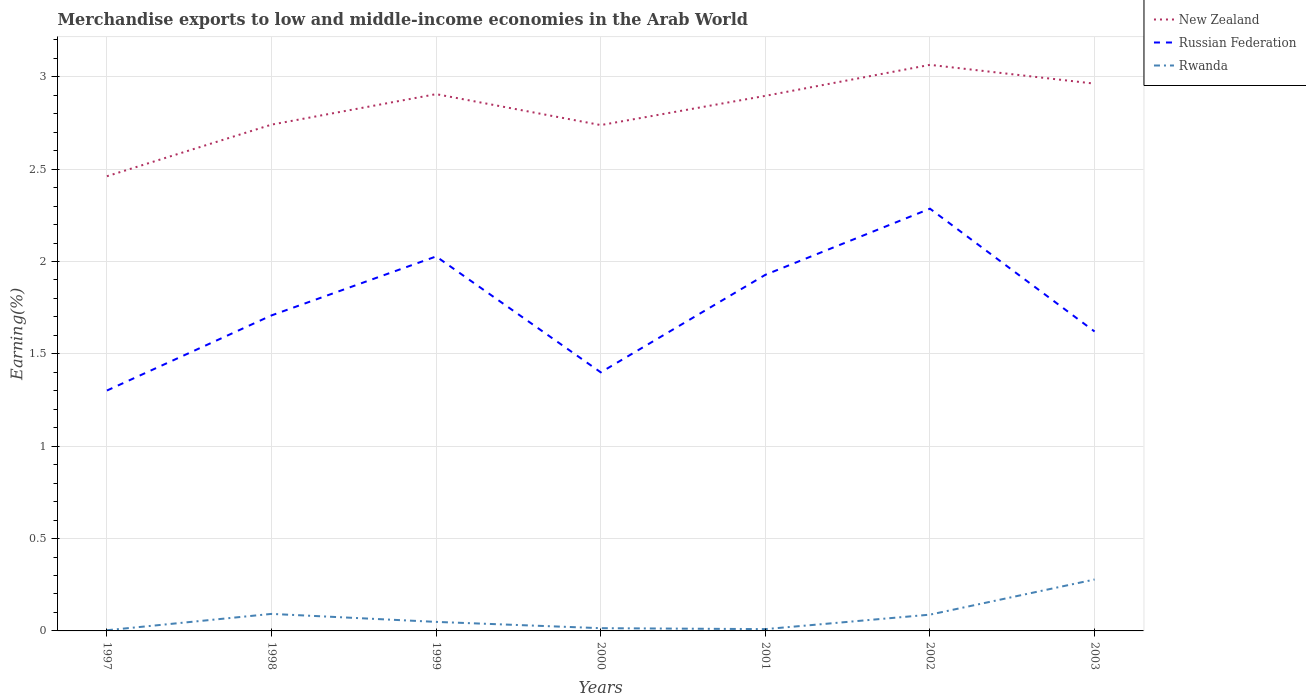How many different coloured lines are there?
Provide a short and direct response. 3. Does the line corresponding to Russian Federation intersect with the line corresponding to Rwanda?
Your answer should be compact. No. Is the number of lines equal to the number of legend labels?
Make the answer very short. Yes. Across all years, what is the maximum percentage of amount earned from merchandise exports in New Zealand?
Ensure brevity in your answer.  2.46. In which year was the percentage of amount earned from merchandise exports in Rwanda maximum?
Offer a terse response. 1997. What is the total percentage of amount earned from merchandise exports in Rwanda in the graph?
Keep it short and to the point. 0. What is the difference between the highest and the second highest percentage of amount earned from merchandise exports in Rwanda?
Your answer should be compact. 0.27. How many years are there in the graph?
Ensure brevity in your answer.  7. What is the difference between two consecutive major ticks on the Y-axis?
Provide a succinct answer. 0.5. Where does the legend appear in the graph?
Offer a terse response. Top right. How many legend labels are there?
Make the answer very short. 3. What is the title of the graph?
Give a very brief answer. Merchandise exports to low and middle-income economies in the Arab World. What is the label or title of the X-axis?
Your answer should be very brief. Years. What is the label or title of the Y-axis?
Offer a very short reply. Earning(%). What is the Earning(%) in New Zealand in 1997?
Your answer should be very brief. 2.46. What is the Earning(%) of Russian Federation in 1997?
Keep it short and to the point. 1.3. What is the Earning(%) in Rwanda in 1997?
Ensure brevity in your answer.  0. What is the Earning(%) of New Zealand in 1998?
Offer a very short reply. 2.74. What is the Earning(%) of Russian Federation in 1998?
Your answer should be very brief. 1.71. What is the Earning(%) of Rwanda in 1998?
Give a very brief answer. 0.09. What is the Earning(%) in New Zealand in 1999?
Your answer should be very brief. 2.91. What is the Earning(%) in Russian Federation in 1999?
Your answer should be compact. 2.03. What is the Earning(%) of Rwanda in 1999?
Give a very brief answer. 0.05. What is the Earning(%) in New Zealand in 2000?
Your answer should be compact. 2.74. What is the Earning(%) in Russian Federation in 2000?
Your answer should be compact. 1.4. What is the Earning(%) in Rwanda in 2000?
Keep it short and to the point. 0.01. What is the Earning(%) in New Zealand in 2001?
Keep it short and to the point. 2.9. What is the Earning(%) in Russian Federation in 2001?
Your response must be concise. 1.93. What is the Earning(%) of Rwanda in 2001?
Offer a very short reply. 0.01. What is the Earning(%) of New Zealand in 2002?
Make the answer very short. 3.06. What is the Earning(%) in Russian Federation in 2002?
Your response must be concise. 2.29. What is the Earning(%) of Rwanda in 2002?
Provide a succinct answer. 0.09. What is the Earning(%) of New Zealand in 2003?
Give a very brief answer. 2.96. What is the Earning(%) of Russian Federation in 2003?
Keep it short and to the point. 1.62. What is the Earning(%) in Rwanda in 2003?
Provide a short and direct response. 0.28. Across all years, what is the maximum Earning(%) in New Zealand?
Provide a succinct answer. 3.06. Across all years, what is the maximum Earning(%) in Russian Federation?
Give a very brief answer. 2.29. Across all years, what is the maximum Earning(%) in Rwanda?
Offer a very short reply. 0.28. Across all years, what is the minimum Earning(%) in New Zealand?
Your answer should be very brief. 2.46. Across all years, what is the minimum Earning(%) of Russian Federation?
Ensure brevity in your answer.  1.3. Across all years, what is the minimum Earning(%) in Rwanda?
Provide a succinct answer. 0. What is the total Earning(%) of New Zealand in the graph?
Ensure brevity in your answer.  19.77. What is the total Earning(%) in Russian Federation in the graph?
Your response must be concise. 12.27. What is the total Earning(%) of Rwanda in the graph?
Your answer should be very brief. 0.54. What is the difference between the Earning(%) of New Zealand in 1997 and that in 1998?
Your answer should be very brief. -0.28. What is the difference between the Earning(%) of Russian Federation in 1997 and that in 1998?
Make the answer very short. -0.41. What is the difference between the Earning(%) in Rwanda in 1997 and that in 1998?
Offer a very short reply. -0.09. What is the difference between the Earning(%) of New Zealand in 1997 and that in 1999?
Give a very brief answer. -0.44. What is the difference between the Earning(%) of Russian Federation in 1997 and that in 1999?
Provide a succinct answer. -0.73. What is the difference between the Earning(%) of Rwanda in 1997 and that in 1999?
Make the answer very short. -0.05. What is the difference between the Earning(%) in New Zealand in 1997 and that in 2000?
Your response must be concise. -0.28. What is the difference between the Earning(%) of Russian Federation in 1997 and that in 2000?
Your response must be concise. -0.1. What is the difference between the Earning(%) of Rwanda in 1997 and that in 2000?
Your answer should be very brief. -0.01. What is the difference between the Earning(%) in New Zealand in 1997 and that in 2001?
Your response must be concise. -0.44. What is the difference between the Earning(%) in Russian Federation in 1997 and that in 2001?
Offer a terse response. -0.63. What is the difference between the Earning(%) of Rwanda in 1997 and that in 2001?
Make the answer very short. -0.01. What is the difference between the Earning(%) in New Zealand in 1997 and that in 2002?
Provide a short and direct response. -0.6. What is the difference between the Earning(%) of Russian Federation in 1997 and that in 2002?
Make the answer very short. -0.98. What is the difference between the Earning(%) of Rwanda in 1997 and that in 2002?
Give a very brief answer. -0.08. What is the difference between the Earning(%) in New Zealand in 1997 and that in 2003?
Your answer should be compact. -0.5. What is the difference between the Earning(%) of Russian Federation in 1997 and that in 2003?
Provide a short and direct response. -0.32. What is the difference between the Earning(%) of Rwanda in 1997 and that in 2003?
Your answer should be compact. -0.27. What is the difference between the Earning(%) of New Zealand in 1998 and that in 1999?
Offer a terse response. -0.17. What is the difference between the Earning(%) of Russian Federation in 1998 and that in 1999?
Offer a terse response. -0.32. What is the difference between the Earning(%) of Rwanda in 1998 and that in 1999?
Offer a terse response. 0.04. What is the difference between the Earning(%) of New Zealand in 1998 and that in 2000?
Your answer should be very brief. 0. What is the difference between the Earning(%) in Russian Federation in 1998 and that in 2000?
Make the answer very short. 0.31. What is the difference between the Earning(%) of Rwanda in 1998 and that in 2000?
Your response must be concise. 0.08. What is the difference between the Earning(%) in New Zealand in 1998 and that in 2001?
Keep it short and to the point. -0.16. What is the difference between the Earning(%) of Russian Federation in 1998 and that in 2001?
Your answer should be very brief. -0.22. What is the difference between the Earning(%) in Rwanda in 1998 and that in 2001?
Offer a terse response. 0.08. What is the difference between the Earning(%) of New Zealand in 1998 and that in 2002?
Your response must be concise. -0.32. What is the difference between the Earning(%) of Russian Federation in 1998 and that in 2002?
Your answer should be compact. -0.58. What is the difference between the Earning(%) in Rwanda in 1998 and that in 2002?
Your answer should be compact. 0. What is the difference between the Earning(%) in New Zealand in 1998 and that in 2003?
Your response must be concise. -0.22. What is the difference between the Earning(%) in Russian Federation in 1998 and that in 2003?
Keep it short and to the point. 0.09. What is the difference between the Earning(%) of Rwanda in 1998 and that in 2003?
Your answer should be compact. -0.19. What is the difference between the Earning(%) in New Zealand in 1999 and that in 2000?
Offer a terse response. 0.17. What is the difference between the Earning(%) of Russian Federation in 1999 and that in 2000?
Provide a succinct answer. 0.63. What is the difference between the Earning(%) of Rwanda in 1999 and that in 2000?
Ensure brevity in your answer.  0.03. What is the difference between the Earning(%) of New Zealand in 1999 and that in 2001?
Provide a short and direct response. 0.01. What is the difference between the Earning(%) of Russian Federation in 1999 and that in 2001?
Your answer should be compact. 0.1. What is the difference between the Earning(%) of Rwanda in 1999 and that in 2001?
Keep it short and to the point. 0.04. What is the difference between the Earning(%) of New Zealand in 1999 and that in 2002?
Your response must be concise. -0.16. What is the difference between the Earning(%) in Russian Federation in 1999 and that in 2002?
Ensure brevity in your answer.  -0.26. What is the difference between the Earning(%) of Rwanda in 1999 and that in 2002?
Give a very brief answer. -0.04. What is the difference between the Earning(%) in New Zealand in 1999 and that in 2003?
Your answer should be compact. -0.06. What is the difference between the Earning(%) in Russian Federation in 1999 and that in 2003?
Make the answer very short. 0.41. What is the difference between the Earning(%) of Rwanda in 1999 and that in 2003?
Offer a terse response. -0.23. What is the difference between the Earning(%) in New Zealand in 2000 and that in 2001?
Offer a very short reply. -0.16. What is the difference between the Earning(%) in Russian Federation in 2000 and that in 2001?
Provide a short and direct response. -0.53. What is the difference between the Earning(%) of Rwanda in 2000 and that in 2001?
Your response must be concise. 0.01. What is the difference between the Earning(%) of New Zealand in 2000 and that in 2002?
Make the answer very short. -0.33. What is the difference between the Earning(%) in Russian Federation in 2000 and that in 2002?
Make the answer very short. -0.89. What is the difference between the Earning(%) of Rwanda in 2000 and that in 2002?
Offer a very short reply. -0.07. What is the difference between the Earning(%) of New Zealand in 2000 and that in 2003?
Give a very brief answer. -0.22. What is the difference between the Earning(%) in Russian Federation in 2000 and that in 2003?
Provide a succinct answer. -0.22. What is the difference between the Earning(%) in Rwanda in 2000 and that in 2003?
Keep it short and to the point. -0.26. What is the difference between the Earning(%) of New Zealand in 2001 and that in 2002?
Give a very brief answer. -0.17. What is the difference between the Earning(%) in Russian Federation in 2001 and that in 2002?
Offer a terse response. -0.36. What is the difference between the Earning(%) of Rwanda in 2001 and that in 2002?
Your answer should be very brief. -0.08. What is the difference between the Earning(%) in New Zealand in 2001 and that in 2003?
Keep it short and to the point. -0.07. What is the difference between the Earning(%) in Russian Federation in 2001 and that in 2003?
Give a very brief answer. 0.31. What is the difference between the Earning(%) in Rwanda in 2001 and that in 2003?
Make the answer very short. -0.27. What is the difference between the Earning(%) of New Zealand in 2002 and that in 2003?
Offer a very short reply. 0.1. What is the difference between the Earning(%) in Russian Federation in 2002 and that in 2003?
Keep it short and to the point. 0.67. What is the difference between the Earning(%) of Rwanda in 2002 and that in 2003?
Make the answer very short. -0.19. What is the difference between the Earning(%) in New Zealand in 1997 and the Earning(%) in Russian Federation in 1998?
Make the answer very short. 0.75. What is the difference between the Earning(%) of New Zealand in 1997 and the Earning(%) of Rwanda in 1998?
Keep it short and to the point. 2.37. What is the difference between the Earning(%) of Russian Federation in 1997 and the Earning(%) of Rwanda in 1998?
Offer a very short reply. 1.21. What is the difference between the Earning(%) of New Zealand in 1997 and the Earning(%) of Russian Federation in 1999?
Provide a short and direct response. 0.43. What is the difference between the Earning(%) in New Zealand in 1997 and the Earning(%) in Rwanda in 1999?
Keep it short and to the point. 2.41. What is the difference between the Earning(%) of Russian Federation in 1997 and the Earning(%) of Rwanda in 1999?
Offer a very short reply. 1.25. What is the difference between the Earning(%) of New Zealand in 1997 and the Earning(%) of Russian Federation in 2000?
Make the answer very short. 1.06. What is the difference between the Earning(%) of New Zealand in 1997 and the Earning(%) of Rwanda in 2000?
Offer a very short reply. 2.45. What is the difference between the Earning(%) of Russian Federation in 1997 and the Earning(%) of Rwanda in 2000?
Give a very brief answer. 1.29. What is the difference between the Earning(%) in New Zealand in 1997 and the Earning(%) in Russian Federation in 2001?
Your answer should be very brief. 0.53. What is the difference between the Earning(%) of New Zealand in 1997 and the Earning(%) of Rwanda in 2001?
Ensure brevity in your answer.  2.45. What is the difference between the Earning(%) in Russian Federation in 1997 and the Earning(%) in Rwanda in 2001?
Provide a short and direct response. 1.29. What is the difference between the Earning(%) of New Zealand in 1997 and the Earning(%) of Russian Federation in 2002?
Give a very brief answer. 0.18. What is the difference between the Earning(%) in New Zealand in 1997 and the Earning(%) in Rwanda in 2002?
Provide a short and direct response. 2.37. What is the difference between the Earning(%) of Russian Federation in 1997 and the Earning(%) of Rwanda in 2002?
Keep it short and to the point. 1.21. What is the difference between the Earning(%) in New Zealand in 1997 and the Earning(%) in Russian Federation in 2003?
Your answer should be compact. 0.84. What is the difference between the Earning(%) in New Zealand in 1997 and the Earning(%) in Rwanda in 2003?
Make the answer very short. 2.18. What is the difference between the Earning(%) in New Zealand in 1998 and the Earning(%) in Russian Federation in 1999?
Your response must be concise. 0.71. What is the difference between the Earning(%) in New Zealand in 1998 and the Earning(%) in Rwanda in 1999?
Give a very brief answer. 2.69. What is the difference between the Earning(%) of Russian Federation in 1998 and the Earning(%) of Rwanda in 1999?
Your answer should be very brief. 1.66. What is the difference between the Earning(%) in New Zealand in 1998 and the Earning(%) in Russian Federation in 2000?
Your response must be concise. 1.34. What is the difference between the Earning(%) of New Zealand in 1998 and the Earning(%) of Rwanda in 2000?
Offer a very short reply. 2.73. What is the difference between the Earning(%) of Russian Federation in 1998 and the Earning(%) of Rwanda in 2000?
Ensure brevity in your answer.  1.69. What is the difference between the Earning(%) of New Zealand in 1998 and the Earning(%) of Russian Federation in 2001?
Your response must be concise. 0.81. What is the difference between the Earning(%) in New Zealand in 1998 and the Earning(%) in Rwanda in 2001?
Ensure brevity in your answer.  2.73. What is the difference between the Earning(%) in Russian Federation in 1998 and the Earning(%) in Rwanda in 2001?
Ensure brevity in your answer.  1.7. What is the difference between the Earning(%) of New Zealand in 1998 and the Earning(%) of Russian Federation in 2002?
Keep it short and to the point. 0.46. What is the difference between the Earning(%) in New Zealand in 1998 and the Earning(%) in Rwanda in 2002?
Your response must be concise. 2.65. What is the difference between the Earning(%) of Russian Federation in 1998 and the Earning(%) of Rwanda in 2002?
Your response must be concise. 1.62. What is the difference between the Earning(%) in New Zealand in 1998 and the Earning(%) in Russian Federation in 2003?
Your answer should be very brief. 1.12. What is the difference between the Earning(%) in New Zealand in 1998 and the Earning(%) in Rwanda in 2003?
Give a very brief answer. 2.46. What is the difference between the Earning(%) in Russian Federation in 1998 and the Earning(%) in Rwanda in 2003?
Your answer should be very brief. 1.43. What is the difference between the Earning(%) of New Zealand in 1999 and the Earning(%) of Russian Federation in 2000?
Provide a succinct answer. 1.51. What is the difference between the Earning(%) of New Zealand in 1999 and the Earning(%) of Rwanda in 2000?
Your answer should be very brief. 2.89. What is the difference between the Earning(%) of Russian Federation in 1999 and the Earning(%) of Rwanda in 2000?
Ensure brevity in your answer.  2.01. What is the difference between the Earning(%) in New Zealand in 1999 and the Earning(%) in Russian Federation in 2001?
Offer a terse response. 0.98. What is the difference between the Earning(%) in New Zealand in 1999 and the Earning(%) in Rwanda in 2001?
Offer a terse response. 2.9. What is the difference between the Earning(%) of Russian Federation in 1999 and the Earning(%) of Rwanda in 2001?
Ensure brevity in your answer.  2.02. What is the difference between the Earning(%) of New Zealand in 1999 and the Earning(%) of Russian Federation in 2002?
Give a very brief answer. 0.62. What is the difference between the Earning(%) of New Zealand in 1999 and the Earning(%) of Rwanda in 2002?
Your response must be concise. 2.82. What is the difference between the Earning(%) in Russian Federation in 1999 and the Earning(%) in Rwanda in 2002?
Provide a succinct answer. 1.94. What is the difference between the Earning(%) of New Zealand in 1999 and the Earning(%) of Russian Federation in 2003?
Provide a succinct answer. 1.29. What is the difference between the Earning(%) in New Zealand in 1999 and the Earning(%) in Rwanda in 2003?
Your response must be concise. 2.63. What is the difference between the Earning(%) of Russian Federation in 1999 and the Earning(%) of Rwanda in 2003?
Provide a short and direct response. 1.75. What is the difference between the Earning(%) of New Zealand in 2000 and the Earning(%) of Russian Federation in 2001?
Your answer should be compact. 0.81. What is the difference between the Earning(%) in New Zealand in 2000 and the Earning(%) in Rwanda in 2001?
Offer a very short reply. 2.73. What is the difference between the Earning(%) of Russian Federation in 2000 and the Earning(%) of Rwanda in 2001?
Provide a short and direct response. 1.39. What is the difference between the Earning(%) of New Zealand in 2000 and the Earning(%) of Russian Federation in 2002?
Your answer should be compact. 0.45. What is the difference between the Earning(%) of New Zealand in 2000 and the Earning(%) of Rwanda in 2002?
Ensure brevity in your answer.  2.65. What is the difference between the Earning(%) of Russian Federation in 2000 and the Earning(%) of Rwanda in 2002?
Your response must be concise. 1.31. What is the difference between the Earning(%) in New Zealand in 2000 and the Earning(%) in Russian Federation in 2003?
Offer a very short reply. 1.12. What is the difference between the Earning(%) in New Zealand in 2000 and the Earning(%) in Rwanda in 2003?
Provide a succinct answer. 2.46. What is the difference between the Earning(%) of Russian Federation in 2000 and the Earning(%) of Rwanda in 2003?
Provide a short and direct response. 1.12. What is the difference between the Earning(%) in New Zealand in 2001 and the Earning(%) in Russian Federation in 2002?
Your response must be concise. 0.61. What is the difference between the Earning(%) of New Zealand in 2001 and the Earning(%) of Rwanda in 2002?
Your response must be concise. 2.81. What is the difference between the Earning(%) of Russian Federation in 2001 and the Earning(%) of Rwanda in 2002?
Keep it short and to the point. 1.84. What is the difference between the Earning(%) of New Zealand in 2001 and the Earning(%) of Russian Federation in 2003?
Keep it short and to the point. 1.28. What is the difference between the Earning(%) of New Zealand in 2001 and the Earning(%) of Rwanda in 2003?
Your response must be concise. 2.62. What is the difference between the Earning(%) of Russian Federation in 2001 and the Earning(%) of Rwanda in 2003?
Your response must be concise. 1.65. What is the difference between the Earning(%) in New Zealand in 2002 and the Earning(%) in Russian Federation in 2003?
Your response must be concise. 1.44. What is the difference between the Earning(%) of New Zealand in 2002 and the Earning(%) of Rwanda in 2003?
Provide a short and direct response. 2.79. What is the difference between the Earning(%) of Russian Federation in 2002 and the Earning(%) of Rwanda in 2003?
Give a very brief answer. 2.01. What is the average Earning(%) in New Zealand per year?
Your answer should be compact. 2.82. What is the average Earning(%) in Russian Federation per year?
Offer a terse response. 1.75. What is the average Earning(%) of Rwanda per year?
Offer a very short reply. 0.08. In the year 1997, what is the difference between the Earning(%) in New Zealand and Earning(%) in Russian Federation?
Offer a terse response. 1.16. In the year 1997, what is the difference between the Earning(%) of New Zealand and Earning(%) of Rwanda?
Ensure brevity in your answer.  2.46. In the year 1997, what is the difference between the Earning(%) of Russian Federation and Earning(%) of Rwanda?
Give a very brief answer. 1.3. In the year 1998, what is the difference between the Earning(%) in New Zealand and Earning(%) in Russian Federation?
Offer a very short reply. 1.03. In the year 1998, what is the difference between the Earning(%) in New Zealand and Earning(%) in Rwanda?
Provide a short and direct response. 2.65. In the year 1998, what is the difference between the Earning(%) in Russian Federation and Earning(%) in Rwanda?
Provide a succinct answer. 1.62. In the year 1999, what is the difference between the Earning(%) of New Zealand and Earning(%) of Russian Federation?
Your response must be concise. 0.88. In the year 1999, what is the difference between the Earning(%) in New Zealand and Earning(%) in Rwanda?
Make the answer very short. 2.86. In the year 1999, what is the difference between the Earning(%) of Russian Federation and Earning(%) of Rwanda?
Your response must be concise. 1.98. In the year 2000, what is the difference between the Earning(%) of New Zealand and Earning(%) of Russian Federation?
Offer a very short reply. 1.34. In the year 2000, what is the difference between the Earning(%) in New Zealand and Earning(%) in Rwanda?
Your answer should be compact. 2.72. In the year 2000, what is the difference between the Earning(%) of Russian Federation and Earning(%) of Rwanda?
Provide a succinct answer. 1.39. In the year 2001, what is the difference between the Earning(%) in New Zealand and Earning(%) in Russian Federation?
Offer a terse response. 0.97. In the year 2001, what is the difference between the Earning(%) of New Zealand and Earning(%) of Rwanda?
Ensure brevity in your answer.  2.89. In the year 2001, what is the difference between the Earning(%) in Russian Federation and Earning(%) in Rwanda?
Your answer should be very brief. 1.92. In the year 2002, what is the difference between the Earning(%) in New Zealand and Earning(%) in Russian Federation?
Your response must be concise. 0.78. In the year 2002, what is the difference between the Earning(%) in New Zealand and Earning(%) in Rwanda?
Provide a short and direct response. 2.98. In the year 2002, what is the difference between the Earning(%) of Russian Federation and Earning(%) of Rwanda?
Make the answer very short. 2.2. In the year 2003, what is the difference between the Earning(%) of New Zealand and Earning(%) of Russian Federation?
Ensure brevity in your answer.  1.34. In the year 2003, what is the difference between the Earning(%) of New Zealand and Earning(%) of Rwanda?
Make the answer very short. 2.68. In the year 2003, what is the difference between the Earning(%) of Russian Federation and Earning(%) of Rwanda?
Offer a very short reply. 1.34. What is the ratio of the Earning(%) in New Zealand in 1997 to that in 1998?
Give a very brief answer. 0.9. What is the ratio of the Earning(%) in Russian Federation in 1997 to that in 1998?
Provide a short and direct response. 0.76. What is the ratio of the Earning(%) of Rwanda in 1997 to that in 1998?
Provide a short and direct response. 0.04. What is the ratio of the Earning(%) of New Zealand in 1997 to that in 1999?
Keep it short and to the point. 0.85. What is the ratio of the Earning(%) of Russian Federation in 1997 to that in 1999?
Give a very brief answer. 0.64. What is the ratio of the Earning(%) of Rwanda in 1997 to that in 1999?
Your answer should be very brief. 0.07. What is the ratio of the Earning(%) in New Zealand in 1997 to that in 2000?
Give a very brief answer. 0.9. What is the ratio of the Earning(%) in Russian Federation in 1997 to that in 2000?
Your answer should be compact. 0.93. What is the ratio of the Earning(%) in Rwanda in 1997 to that in 2000?
Keep it short and to the point. 0.25. What is the ratio of the Earning(%) of New Zealand in 1997 to that in 2001?
Provide a succinct answer. 0.85. What is the ratio of the Earning(%) in Russian Federation in 1997 to that in 2001?
Your answer should be very brief. 0.68. What is the ratio of the Earning(%) in Rwanda in 1997 to that in 2001?
Provide a short and direct response. 0.37. What is the ratio of the Earning(%) of New Zealand in 1997 to that in 2002?
Your answer should be very brief. 0.8. What is the ratio of the Earning(%) in Russian Federation in 1997 to that in 2002?
Keep it short and to the point. 0.57. What is the ratio of the Earning(%) of Rwanda in 1997 to that in 2002?
Make the answer very short. 0.04. What is the ratio of the Earning(%) in New Zealand in 1997 to that in 2003?
Give a very brief answer. 0.83. What is the ratio of the Earning(%) in Russian Federation in 1997 to that in 2003?
Keep it short and to the point. 0.8. What is the ratio of the Earning(%) of Rwanda in 1997 to that in 2003?
Your answer should be very brief. 0.01. What is the ratio of the Earning(%) of New Zealand in 1998 to that in 1999?
Offer a very short reply. 0.94. What is the ratio of the Earning(%) of Russian Federation in 1998 to that in 1999?
Offer a terse response. 0.84. What is the ratio of the Earning(%) of Rwanda in 1998 to that in 1999?
Make the answer very short. 1.89. What is the ratio of the Earning(%) in Russian Federation in 1998 to that in 2000?
Give a very brief answer. 1.22. What is the ratio of the Earning(%) of Rwanda in 1998 to that in 2000?
Provide a succinct answer. 6.22. What is the ratio of the Earning(%) in New Zealand in 1998 to that in 2001?
Your answer should be compact. 0.95. What is the ratio of the Earning(%) of Russian Federation in 1998 to that in 2001?
Keep it short and to the point. 0.89. What is the ratio of the Earning(%) in Rwanda in 1998 to that in 2001?
Offer a very short reply. 9.45. What is the ratio of the Earning(%) of New Zealand in 1998 to that in 2002?
Provide a short and direct response. 0.89. What is the ratio of the Earning(%) of Russian Federation in 1998 to that in 2002?
Offer a very short reply. 0.75. What is the ratio of the Earning(%) in Rwanda in 1998 to that in 2002?
Ensure brevity in your answer.  1.05. What is the ratio of the Earning(%) in New Zealand in 1998 to that in 2003?
Offer a very short reply. 0.93. What is the ratio of the Earning(%) of Russian Federation in 1998 to that in 2003?
Ensure brevity in your answer.  1.05. What is the ratio of the Earning(%) in Rwanda in 1998 to that in 2003?
Make the answer very short. 0.33. What is the ratio of the Earning(%) in New Zealand in 1999 to that in 2000?
Give a very brief answer. 1.06. What is the ratio of the Earning(%) of Russian Federation in 1999 to that in 2000?
Your answer should be very brief. 1.45. What is the ratio of the Earning(%) in Rwanda in 1999 to that in 2000?
Make the answer very short. 3.3. What is the ratio of the Earning(%) of Russian Federation in 1999 to that in 2001?
Offer a terse response. 1.05. What is the ratio of the Earning(%) of Rwanda in 1999 to that in 2001?
Provide a succinct answer. 5.01. What is the ratio of the Earning(%) of New Zealand in 1999 to that in 2002?
Offer a terse response. 0.95. What is the ratio of the Earning(%) in Russian Federation in 1999 to that in 2002?
Offer a very short reply. 0.89. What is the ratio of the Earning(%) of Rwanda in 1999 to that in 2002?
Ensure brevity in your answer.  0.55. What is the ratio of the Earning(%) in New Zealand in 1999 to that in 2003?
Offer a very short reply. 0.98. What is the ratio of the Earning(%) in Russian Federation in 1999 to that in 2003?
Keep it short and to the point. 1.25. What is the ratio of the Earning(%) in Rwanda in 1999 to that in 2003?
Make the answer very short. 0.18. What is the ratio of the Earning(%) in New Zealand in 2000 to that in 2001?
Your response must be concise. 0.95. What is the ratio of the Earning(%) of Russian Federation in 2000 to that in 2001?
Your answer should be very brief. 0.73. What is the ratio of the Earning(%) of Rwanda in 2000 to that in 2001?
Offer a very short reply. 1.52. What is the ratio of the Earning(%) in New Zealand in 2000 to that in 2002?
Make the answer very short. 0.89. What is the ratio of the Earning(%) of Russian Federation in 2000 to that in 2002?
Your response must be concise. 0.61. What is the ratio of the Earning(%) of Rwanda in 2000 to that in 2002?
Offer a terse response. 0.17. What is the ratio of the Earning(%) of New Zealand in 2000 to that in 2003?
Keep it short and to the point. 0.92. What is the ratio of the Earning(%) of Russian Federation in 2000 to that in 2003?
Your answer should be very brief. 0.86. What is the ratio of the Earning(%) in Rwanda in 2000 to that in 2003?
Provide a succinct answer. 0.05. What is the ratio of the Earning(%) of New Zealand in 2001 to that in 2002?
Your answer should be compact. 0.95. What is the ratio of the Earning(%) of Russian Federation in 2001 to that in 2002?
Ensure brevity in your answer.  0.84. What is the ratio of the Earning(%) of Rwanda in 2001 to that in 2002?
Offer a terse response. 0.11. What is the ratio of the Earning(%) in New Zealand in 2001 to that in 2003?
Give a very brief answer. 0.98. What is the ratio of the Earning(%) of Russian Federation in 2001 to that in 2003?
Keep it short and to the point. 1.19. What is the ratio of the Earning(%) in Rwanda in 2001 to that in 2003?
Keep it short and to the point. 0.04. What is the ratio of the Earning(%) in New Zealand in 2002 to that in 2003?
Your answer should be compact. 1.03. What is the ratio of the Earning(%) in Russian Federation in 2002 to that in 2003?
Offer a terse response. 1.41. What is the ratio of the Earning(%) of Rwanda in 2002 to that in 2003?
Provide a short and direct response. 0.32. What is the difference between the highest and the second highest Earning(%) in New Zealand?
Ensure brevity in your answer.  0.1. What is the difference between the highest and the second highest Earning(%) in Russian Federation?
Make the answer very short. 0.26. What is the difference between the highest and the second highest Earning(%) in Rwanda?
Provide a succinct answer. 0.19. What is the difference between the highest and the lowest Earning(%) of New Zealand?
Your response must be concise. 0.6. What is the difference between the highest and the lowest Earning(%) of Russian Federation?
Offer a very short reply. 0.98. What is the difference between the highest and the lowest Earning(%) in Rwanda?
Your answer should be very brief. 0.27. 